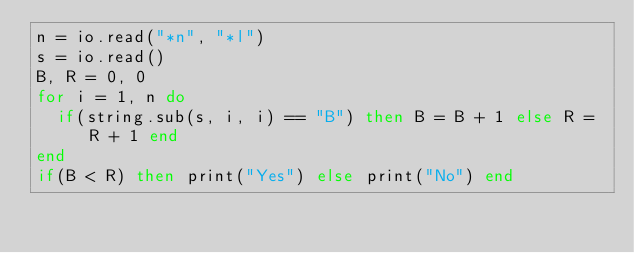Convert code to text. <code><loc_0><loc_0><loc_500><loc_500><_Lua_>n = io.read("*n", "*l")
s = io.read()
B, R = 0, 0
for i = 1, n do
  if(string.sub(s, i, i) == "B") then B = B + 1 else R = R + 1 end
end
if(B < R) then print("Yes") else print("No") end</code> 